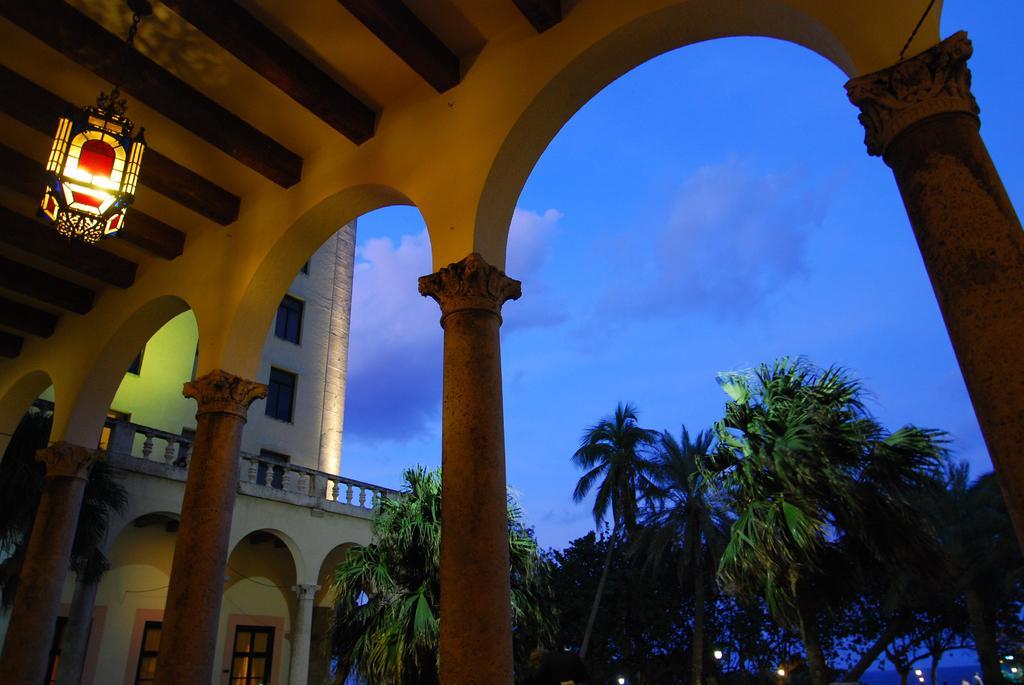Could you give a brief overview of what you see in this image? In this picture we can see lamp, pillars, building, windows, lights and trees. In the background of the image we can see sky with clouds. 